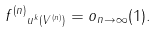<formula> <loc_0><loc_0><loc_500><loc_500>\| f ^ { ( n ) } \| _ { u ^ { k } ( V ^ { ( n ) } ) } = o _ { n \to \infty } ( 1 ) .</formula> 